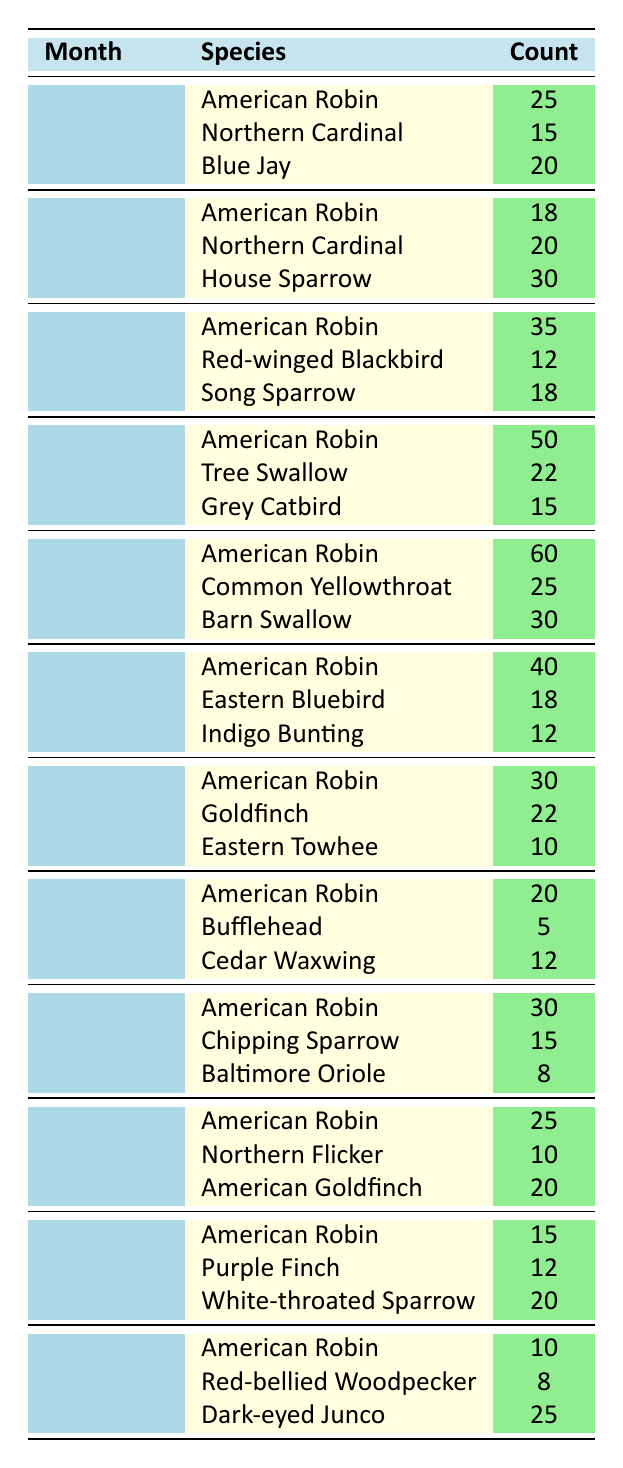What is the highest count for the American Robin in a single month? Looking at the monthly counts for the American Robin, the highest count appears in May with 60 sightings.
Answer: 60 In which month was the Northern Cardinal sighted the most? The Northern Cardinal was sighted the most in February with a count of 20.
Answer: February How many species were recorded in June? In June, there are three species listed: American Robin, Eastern Bluebird, and Indigo Bunting.
Answer: 3 What is the total count of bird sightings for the month of April? Adding the counts for April gives: 50 (American Robin) + 22 (Tree Swallow) + 15 (Grey Catbird) = 87.
Answer: 87 Is the Baltimore Oriole sighted more than the Cedar Waxwing in any month? The Baltimore Oriole, with a maximum of 8 sightings in September, was not sighted more than the Cedar Waxwing, which had 12 sightings in August.
Answer: No What is the average count of sightings for the American Robin across the entire year? The counts for the American Robin across the months are: 25, 18, 35, 50, 60, 40, 30, 20, 30, 25, 15, and 10. Summing these gives 25 + 18 + 35 + 50 + 60 + 40 + 30 + 20 + 30 + 25 + 15 + 10 =  30.5. There are 12 months, so the average is 366/12 = 30.5.
Answer: 30.5 Which species had the least sightings in July? In July, the Eastern Towhee had the least count with only 10 sightings.
Answer: Eastern Towhee How does the count of Dark-eyed Junco in December compare to the American Goldfinch in October? The Dark-eyed Junco in December had 25 sightings, while the American Goldfinch in October had 20 sightings. Thus, the Dark-eyed Junco had more sightings.
Answer: More What species had the highest combined count in the months of June and July? For June, the counts were 40 (American Robin), 18 (Eastern Bluebird), and 12 (Indigo Bunting), totaling 70. For July, the counts were 30 (American Robin), 22 (Goldfinch), and 10 (Eastern Towhee), totaling 62. Combined, American Robin has the highest total with 40 + 30 = 70, equal to the June count.
Answer: American Robin 